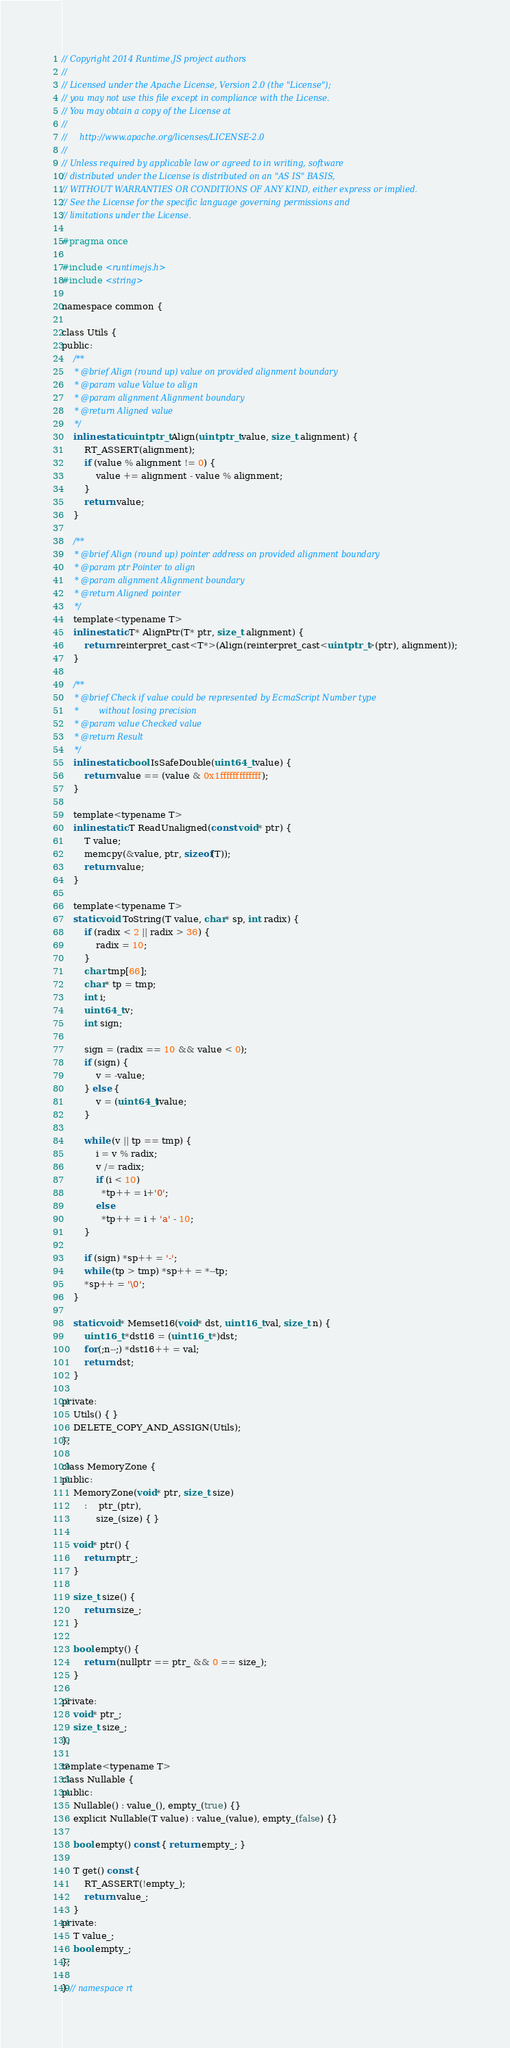<code> <loc_0><loc_0><loc_500><loc_500><_C_>// Copyright 2014 Runtime.JS project authors
//
// Licensed under the Apache License, Version 2.0 (the "License");
// you may not use this file except in compliance with the License.
// You may obtain a copy of the License at
//
//     http://www.apache.org/licenses/LICENSE-2.0
//
// Unless required by applicable law or agreed to in writing, software
// distributed under the License is distributed on an "AS IS" BASIS,
// WITHOUT WARRANTIES OR CONDITIONS OF ANY KIND, either express or implied.
// See the License for the specific language governing permissions and
// limitations under the License.

#pragma once

#include <runtimejs.h>
#include <string>

namespace common {

class Utils {
public:
    /**
     * @brief Align (round up) value on provided alignment boundary
     * @param value Value to align
     * @param alignment Alignment boundary
     * @return Aligned value
     */
    inline static uintptr_t Align(uintptr_t value, size_t alignment) {
        RT_ASSERT(alignment);
        if (value % alignment != 0) {
            value += alignment - value % alignment;
        }
        return value;
    }

    /**
     * @brief Align (round up) pointer address on provided alignment boundary
     * @param ptr Pointer to align
     * @param alignment Alignment boundary
     * @return Aligned pointer
     */
    template<typename T>
    inline static T* AlignPtr(T* ptr, size_t alignment) {
        return reinterpret_cast<T*>(Align(reinterpret_cast<uintptr_t>(ptr), alignment));
    }

    /**
     * @brief Check if value could be represented by EcmaScript Number type
     *        without losing precision
     * @param value Checked value
     * @return Result
     */
    inline static bool IsSafeDouble(uint64_t value) {
        return value == (value & 0x1fffffffffffff);
    }

    template<typename T>
    inline static T ReadUnaligned(const void* ptr) {
        T value;
        memcpy(&value, ptr, sizeof(T));
        return value;
    }

    template<typename T>
    static void ToString(T value, char* sp, int radix) {
        if (radix < 2 || radix > 36) {
            radix = 10;
        }
        char tmp[66];
        char* tp = tmp;
        int i;
        uint64_t v;
        int sign;

        sign = (radix == 10 && value < 0);
        if (sign) {
            v = -value;
        } else {
            v = (uint64_t)value;
        }

        while (v || tp == tmp) {
            i = v % radix;
            v /= radix;
            if (i < 10)
              *tp++ = i+'0';
            else
              *tp++ = i + 'a' - 10;
        }

        if (sign) *sp++ = '-';
        while (tp > tmp) *sp++ = *--tp;
        *sp++ = '\0';
    }

    static void* Memset16(void* dst, uint16_t val, size_t n) {
        uint16_t *dst16 = (uint16_t *)dst;
        for(;n--;) *dst16++ = val;
        return dst;
    }

private:
    Utils() { }
    DELETE_COPY_AND_ASSIGN(Utils);
};

class MemoryZone {
public:
    MemoryZone(void* ptr, size_t size)
        :	ptr_(ptr),
            size_(size) { }

    void* ptr() {
        return ptr_;
    }

    size_t size() {
        return size_;
    }

    bool empty() {
        return (nullptr == ptr_ && 0 == size_);
    }

private:
    void* ptr_;
    size_t size_;
};

template<typename T>
class Nullable {
public:
    Nullable() : value_(), empty_(true) {}
    explicit Nullable(T value) : value_(value), empty_(false) {}

    bool empty() const { return empty_; }

    T get() const {
        RT_ASSERT(!empty_);
        return value_;
    }
private:
    T value_;
    bool empty_;
};

} // namespace rt
</code> 